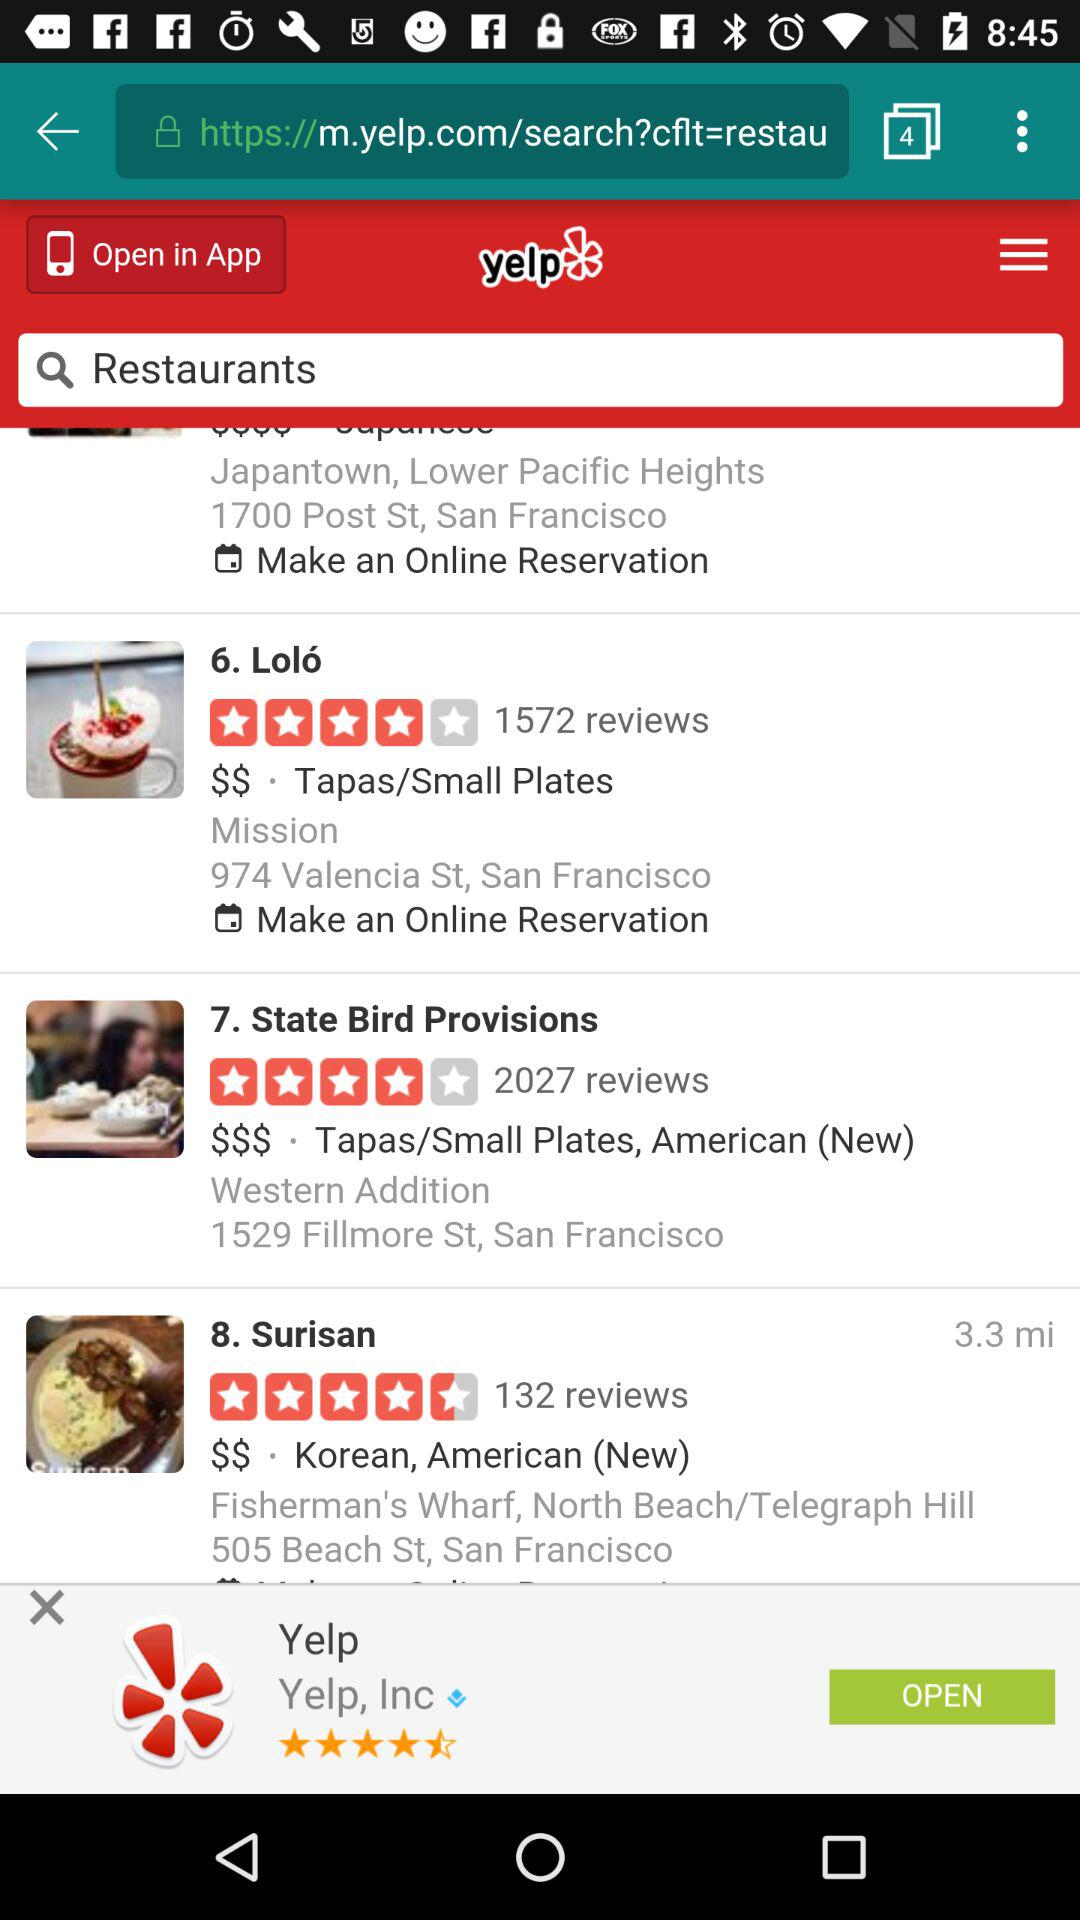What's the address of the Loló restaurant? The address is "974 Valencia St, San Francisco". 